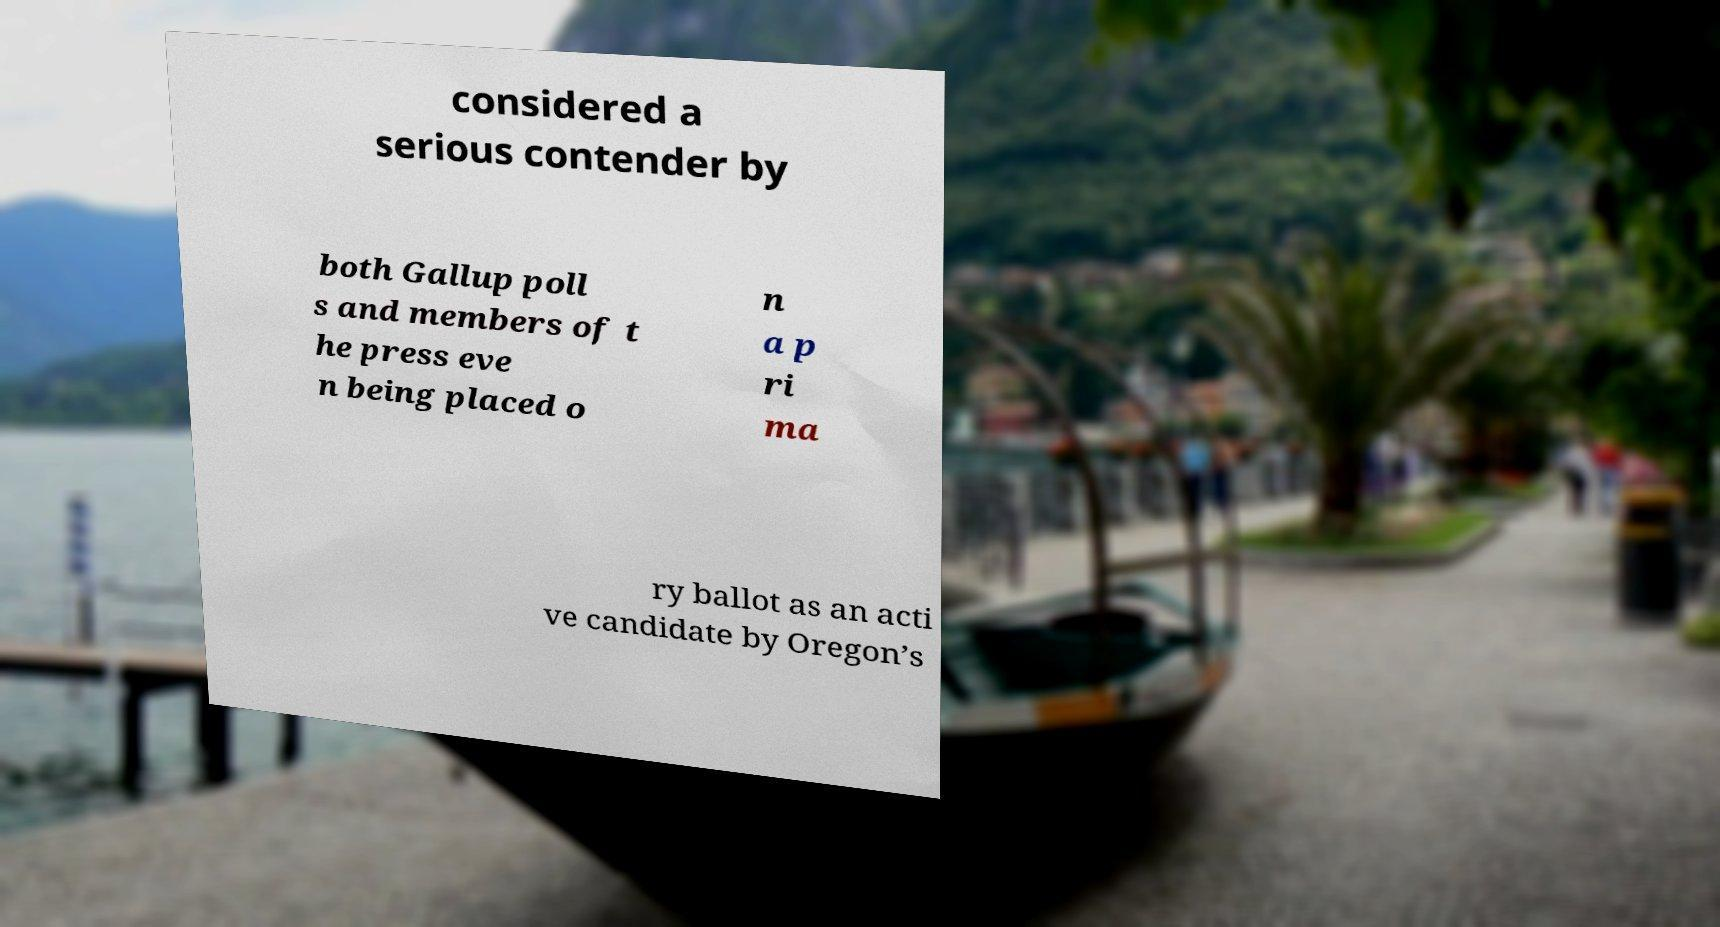There's text embedded in this image that I need extracted. Can you transcribe it verbatim? considered a serious contender by both Gallup poll s and members of t he press eve n being placed o n a p ri ma ry ballot as an acti ve candidate by Oregon’s 